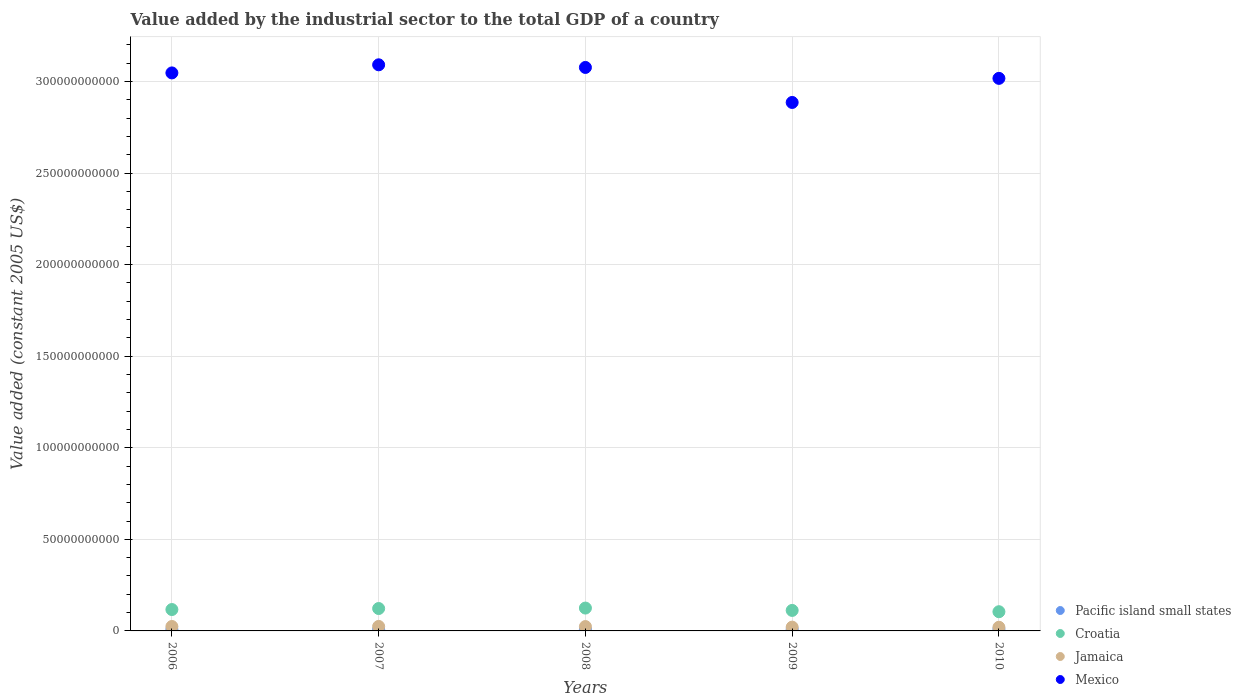Is the number of dotlines equal to the number of legend labels?
Keep it short and to the point. Yes. What is the value added by the industrial sector in Pacific island small states in 2007?
Offer a very short reply. 8.07e+08. Across all years, what is the maximum value added by the industrial sector in Mexico?
Your response must be concise. 3.09e+11. Across all years, what is the minimum value added by the industrial sector in Jamaica?
Provide a short and direct response. 2.00e+09. In which year was the value added by the industrial sector in Jamaica maximum?
Make the answer very short. 2007. What is the total value added by the industrial sector in Pacific island small states in the graph?
Make the answer very short. 4.33e+09. What is the difference between the value added by the industrial sector in Mexico in 2006 and that in 2009?
Make the answer very short. 1.61e+1. What is the difference between the value added by the industrial sector in Croatia in 2006 and the value added by the industrial sector in Pacific island small states in 2008?
Offer a very short reply. 1.08e+1. What is the average value added by the industrial sector in Pacific island small states per year?
Offer a very short reply. 8.65e+08. In the year 2009, what is the difference between the value added by the industrial sector in Jamaica and value added by the industrial sector in Pacific island small states?
Your response must be concise. 1.19e+09. What is the ratio of the value added by the industrial sector in Croatia in 2006 to that in 2008?
Offer a terse response. 0.94. What is the difference between the highest and the second highest value added by the industrial sector in Jamaica?
Your answer should be compact. 3.65e+07. What is the difference between the highest and the lowest value added by the industrial sector in Jamaica?
Provide a succinct answer. 4.54e+08. In how many years, is the value added by the industrial sector in Jamaica greater than the average value added by the industrial sector in Jamaica taken over all years?
Ensure brevity in your answer.  3. Is it the case that in every year, the sum of the value added by the industrial sector in Croatia and value added by the industrial sector in Jamaica  is greater than the sum of value added by the industrial sector in Mexico and value added by the industrial sector in Pacific island small states?
Give a very brief answer. Yes. Does the value added by the industrial sector in Croatia monotonically increase over the years?
Give a very brief answer. No. Is the value added by the industrial sector in Mexico strictly greater than the value added by the industrial sector in Croatia over the years?
Give a very brief answer. Yes. How many dotlines are there?
Offer a terse response. 4. How many years are there in the graph?
Make the answer very short. 5. Are the values on the major ticks of Y-axis written in scientific E-notation?
Provide a short and direct response. No. Where does the legend appear in the graph?
Make the answer very short. Bottom right. How are the legend labels stacked?
Your response must be concise. Vertical. What is the title of the graph?
Offer a very short reply. Value added by the industrial sector to the total GDP of a country. Does "Guam" appear as one of the legend labels in the graph?
Ensure brevity in your answer.  No. What is the label or title of the Y-axis?
Ensure brevity in your answer.  Value added (constant 2005 US$). What is the Value added (constant 2005 US$) of Pacific island small states in 2006?
Offer a very short reply. 8.22e+08. What is the Value added (constant 2005 US$) in Croatia in 2006?
Your answer should be very brief. 1.17e+1. What is the Value added (constant 2005 US$) of Jamaica in 2006?
Provide a short and direct response. 2.42e+09. What is the Value added (constant 2005 US$) in Mexico in 2006?
Your answer should be compact. 3.05e+11. What is the Value added (constant 2005 US$) in Pacific island small states in 2007?
Your answer should be compact. 8.07e+08. What is the Value added (constant 2005 US$) in Croatia in 2007?
Your answer should be compact. 1.22e+1. What is the Value added (constant 2005 US$) of Jamaica in 2007?
Give a very brief answer. 2.46e+09. What is the Value added (constant 2005 US$) of Mexico in 2007?
Make the answer very short. 3.09e+11. What is the Value added (constant 2005 US$) of Pacific island small states in 2008?
Provide a short and direct response. 8.82e+08. What is the Value added (constant 2005 US$) of Croatia in 2008?
Your answer should be very brief. 1.25e+1. What is the Value added (constant 2005 US$) in Jamaica in 2008?
Your answer should be very brief. 2.38e+09. What is the Value added (constant 2005 US$) of Mexico in 2008?
Your response must be concise. 3.08e+11. What is the Value added (constant 2005 US$) of Pacific island small states in 2009?
Give a very brief answer. 8.78e+08. What is the Value added (constant 2005 US$) of Croatia in 2009?
Provide a succinct answer. 1.12e+1. What is the Value added (constant 2005 US$) of Jamaica in 2009?
Your answer should be very brief. 2.07e+09. What is the Value added (constant 2005 US$) of Mexico in 2009?
Make the answer very short. 2.89e+11. What is the Value added (constant 2005 US$) in Pacific island small states in 2010?
Your answer should be compact. 9.36e+08. What is the Value added (constant 2005 US$) of Croatia in 2010?
Ensure brevity in your answer.  1.05e+1. What is the Value added (constant 2005 US$) of Jamaica in 2010?
Make the answer very short. 2.00e+09. What is the Value added (constant 2005 US$) in Mexico in 2010?
Ensure brevity in your answer.  3.02e+11. Across all years, what is the maximum Value added (constant 2005 US$) of Pacific island small states?
Provide a succinct answer. 9.36e+08. Across all years, what is the maximum Value added (constant 2005 US$) in Croatia?
Your answer should be compact. 1.25e+1. Across all years, what is the maximum Value added (constant 2005 US$) in Jamaica?
Keep it short and to the point. 2.46e+09. Across all years, what is the maximum Value added (constant 2005 US$) of Mexico?
Make the answer very short. 3.09e+11. Across all years, what is the minimum Value added (constant 2005 US$) of Pacific island small states?
Ensure brevity in your answer.  8.07e+08. Across all years, what is the minimum Value added (constant 2005 US$) of Croatia?
Your answer should be compact. 1.05e+1. Across all years, what is the minimum Value added (constant 2005 US$) in Jamaica?
Ensure brevity in your answer.  2.00e+09. Across all years, what is the minimum Value added (constant 2005 US$) of Mexico?
Offer a very short reply. 2.89e+11. What is the total Value added (constant 2005 US$) of Pacific island small states in the graph?
Offer a terse response. 4.33e+09. What is the total Value added (constant 2005 US$) in Croatia in the graph?
Offer a very short reply. 5.81e+1. What is the total Value added (constant 2005 US$) in Jamaica in the graph?
Make the answer very short. 1.13e+1. What is the total Value added (constant 2005 US$) in Mexico in the graph?
Your answer should be very brief. 1.51e+12. What is the difference between the Value added (constant 2005 US$) of Pacific island small states in 2006 and that in 2007?
Your response must be concise. 1.49e+07. What is the difference between the Value added (constant 2005 US$) in Croatia in 2006 and that in 2007?
Provide a succinct answer. -5.57e+08. What is the difference between the Value added (constant 2005 US$) of Jamaica in 2006 and that in 2007?
Your answer should be very brief. -3.65e+07. What is the difference between the Value added (constant 2005 US$) of Mexico in 2006 and that in 2007?
Your answer should be compact. -4.43e+09. What is the difference between the Value added (constant 2005 US$) in Pacific island small states in 2006 and that in 2008?
Provide a succinct answer. -6.06e+07. What is the difference between the Value added (constant 2005 US$) of Croatia in 2006 and that in 2008?
Your answer should be very brief. -8.07e+08. What is the difference between the Value added (constant 2005 US$) of Jamaica in 2006 and that in 2008?
Provide a succinct answer. 4.12e+07. What is the difference between the Value added (constant 2005 US$) in Mexico in 2006 and that in 2008?
Offer a terse response. -2.99e+09. What is the difference between the Value added (constant 2005 US$) of Pacific island small states in 2006 and that in 2009?
Give a very brief answer. -5.68e+07. What is the difference between the Value added (constant 2005 US$) of Croatia in 2006 and that in 2009?
Make the answer very short. 4.80e+08. What is the difference between the Value added (constant 2005 US$) in Jamaica in 2006 and that in 2009?
Offer a terse response. 3.49e+08. What is the difference between the Value added (constant 2005 US$) in Mexico in 2006 and that in 2009?
Your answer should be compact. 1.61e+1. What is the difference between the Value added (constant 2005 US$) in Pacific island small states in 2006 and that in 2010?
Keep it short and to the point. -1.15e+08. What is the difference between the Value added (constant 2005 US$) in Croatia in 2006 and that in 2010?
Your response must be concise. 1.19e+09. What is the difference between the Value added (constant 2005 US$) in Jamaica in 2006 and that in 2010?
Offer a terse response. 4.17e+08. What is the difference between the Value added (constant 2005 US$) in Mexico in 2006 and that in 2010?
Offer a very short reply. 2.98e+09. What is the difference between the Value added (constant 2005 US$) in Pacific island small states in 2007 and that in 2008?
Make the answer very short. -7.55e+07. What is the difference between the Value added (constant 2005 US$) in Croatia in 2007 and that in 2008?
Provide a succinct answer. -2.50e+08. What is the difference between the Value added (constant 2005 US$) in Jamaica in 2007 and that in 2008?
Give a very brief answer. 7.76e+07. What is the difference between the Value added (constant 2005 US$) of Mexico in 2007 and that in 2008?
Make the answer very short. 1.44e+09. What is the difference between the Value added (constant 2005 US$) of Pacific island small states in 2007 and that in 2009?
Your answer should be very brief. -7.17e+07. What is the difference between the Value added (constant 2005 US$) of Croatia in 2007 and that in 2009?
Offer a terse response. 1.04e+09. What is the difference between the Value added (constant 2005 US$) in Jamaica in 2007 and that in 2009?
Your answer should be compact. 3.86e+08. What is the difference between the Value added (constant 2005 US$) in Mexico in 2007 and that in 2009?
Keep it short and to the point. 2.06e+1. What is the difference between the Value added (constant 2005 US$) of Pacific island small states in 2007 and that in 2010?
Make the answer very short. -1.30e+08. What is the difference between the Value added (constant 2005 US$) in Croatia in 2007 and that in 2010?
Keep it short and to the point. 1.74e+09. What is the difference between the Value added (constant 2005 US$) of Jamaica in 2007 and that in 2010?
Your response must be concise. 4.54e+08. What is the difference between the Value added (constant 2005 US$) of Mexico in 2007 and that in 2010?
Offer a very short reply. 7.41e+09. What is the difference between the Value added (constant 2005 US$) of Pacific island small states in 2008 and that in 2009?
Offer a terse response. 3.81e+06. What is the difference between the Value added (constant 2005 US$) in Croatia in 2008 and that in 2009?
Offer a very short reply. 1.29e+09. What is the difference between the Value added (constant 2005 US$) of Jamaica in 2008 and that in 2009?
Give a very brief answer. 3.08e+08. What is the difference between the Value added (constant 2005 US$) of Mexico in 2008 and that in 2009?
Your answer should be very brief. 1.91e+1. What is the difference between the Value added (constant 2005 US$) of Pacific island small states in 2008 and that in 2010?
Provide a succinct answer. -5.43e+07. What is the difference between the Value added (constant 2005 US$) of Croatia in 2008 and that in 2010?
Your answer should be compact. 1.99e+09. What is the difference between the Value added (constant 2005 US$) of Jamaica in 2008 and that in 2010?
Your answer should be compact. 3.76e+08. What is the difference between the Value added (constant 2005 US$) of Mexico in 2008 and that in 2010?
Keep it short and to the point. 5.96e+09. What is the difference between the Value added (constant 2005 US$) of Pacific island small states in 2009 and that in 2010?
Ensure brevity in your answer.  -5.81e+07. What is the difference between the Value added (constant 2005 US$) of Croatia in 2009 and that in 2010?
Keep it short and to the point. 7.07e+08. What is the difference between the Value added (constant 2005 US$) in Jamaica in 2009 and that in 2010?
Offer a terse response. 6.83e+07. What is the difference between the Value added (constant 2005 US$) in Mexico in 2009 and that in 2010?
Give a very brief answer. -1.32e+1. What is the difference between the Value added (constant 2005 US$) of Pacific island small states in 2006 and the Value added (constant 2005 US$) of Croatia in 2007?
Ensure brevity in your answer.  -1.14e+1. What is the difference between the Value added (constant 2005 US$) of Pacific island small states in 2006 and the Value added (constant 2005 US$) of Jamaica in 2007?
Your answer should be compact. -1.64e+09. What is the difference between the Value added (constant 2005 US$) in Pacific island small states in 2006 and the Value added (constant 2005 US$) in Mexico in 2007?
Ensure brevity in your answer.  -3.08e+11. What is the difference between the Value added (constant 2005 US$) of Croatia in 2006 and the Value added (constant 2005 US$) of Jamaica in 2007?
Your answer should be very brief. 9.22e+09. What is the difference between the Value added (constant 2005 US$) of Croatia in 2006 and the Value added (constant 2005 US$) of Mexico in 2007?
Provide a succinct answer. -2.97e+11. What is the difference between the Value added (constant 2005 US$) in Jamaica in 2006 and the Value added (constant 2005 US$) in Mexico in 2007?
Your answer should be compact. -3.07e+11. What is the difference between the Value added (constant 2005 US$) in Pacific island small states in 2006 and the Value added (constant 2005 US$) in Croatia in 2008?
Give a very brief answer. -1.17e+1. What is the difference between the Value added (constant 2005 US$) in Pacific island small states in 2006 and the Value added (constant 2005 US$) in Jamaica in 2008?
Make the answer very short. -1.56e+09. What is the difference between the Value added (constant 2005 US$) of Pacific island small states in 2006 and the Value added (constant 2005 US$) of Mexico in 2008?
Your answer should be compact. -3.07e+11. What is the difference between the Value added (constant 2005 US$) of Croatia in 2006 and the Value added (constant 2005 US$) of Jamaica in 2008?
Your answer should be very brief. 9.29e+09. What is the difference between the Value added (constant 2005 US$) in Croatia in 2006 and the Value added (constant 2005 US$) in Mexico in 2008?
Provide a succinct answer. -2.96e+11. What is the difference between the Value added (constant 2005 US$) of Jamaica in 2006 and the Value added (constant 2005 US$) of Mexico in 2008?
Give a very brief answer. -3.05e+11. What is the difference between the Value added (constant 2005 US$) of Pacific island small states in 2006 and the Value added (constant 2005 US$) of Croatia in 2009?
Your answer should be very brief. -1.04e+1. What is the difference between the Value added (constant 2005 US$) of Pacific island small states in 2006 and the Value added (constant 2005 US$) of Jamaica in 2009?
Provide a short and direct response. -1.25e+09. What is the difference between the Value added (constant 2005 US$) in Pacific island small states in 2006 and the Value added (constant 2005 US$) in Mexico in 2009?
Give a very brief answer. -2.88e+11. What is the difference between the Value added (constant 2005 US$) in Croatia in 2006 and the Value added (constant 2005 US$) in Jamaica in 2009?
Ensure brevity in your answer.  9.60e+09. What is the difference between the Value added (constant 2005 US$) in Croatia in 2006 and the Value added (constant 2005 US$) in Mexico in 2009?
Provide a succinct answer. -2.77e+11. What is the difference between the Value added (constant 2005 US$) in Jamaica in 2006 and the Value added (constant 2005 US$) in Mexico in 2009?
Your answer should be very brief. -2.86e+11. What is the difference between the Value added (constant 2005 US$) in Pacific island small states in 2006 and the Value added (constant 2005 US$) in Croatia in 2010?
Your answer should be compact. -9.67e+09. What is the difference between the Value added (constant 2005 US$) of Pacific island small states in 2006 and the Value added (constant 2005 US$) of Jamaica in 2010?
Offer a terse response. -1.18e+09. What is the difference between the Value added (constant 2005 US$) of Pacific island small states in 2006 and the Value added (constant 2005 US$) of Mexico in 2010?
Provide a succinct answer. -3.01e+11. What is the difference between the Value added (constant 2005 US$) in Croatia in 2006 and the Value added (constant 2005 US$) in Jamaica in 2010?
Ensure brevity in your answer.  9.67e+09. What is the difference between the Value added (constant 2005 US$) in Croatia in 2006 and the Value added (constant 2005 US$) in Mexico in 2010?
Provide a succinct answer. -2.90e+11. What is the difference between the Value added (constant 2005 US$) in Jamaica in 2006 and the Value added (constant 2005 US$) in Mexico in 2010?
Your response must be concise. -2.99e+11. What is the difference between the Value added (constant 2005 US$) in Pacific island small states in 2007 and the Value added (constant 2005 US$) in Croatia in 2008?
Ensure brevity in your answer.  -1.17e+1. What is the difference between the Value added (constant 2005 US$) in Pacific island small states in 2007 and the Value added (constant 2005 US$) in Jamaica in 2008?
Your response must be concise. -1.57e+09. What is the difference between the Value added (constant 2005 US$) in Pacific island small states in 2007 and the Value added (constant 2005 US$) in Mexico in 2008?
Provide a short and direct response. -3.07e+11. What is the difference between the Value added (constant 2005 US$) in Croatia in 2007 and the Value added (constant 2005 US$) in Jamaica in 2008?
Provide a short and direct response. 9.85e+09. What is the difference between the Value added (constant 2005 US$) in Croatia in 2007 and the Value added (constant 2005 US$) in Mexico in 2008?
Ensure brevity in your answer.  -2.95e+11. What is the difference between the Value added (constant 2005 US$) in Jamaica in 2007 and the Value added (constant 2005 US$) in Mexico in 2008?
Your answer should be compact. -3.05e+11. What is the difference between the Value added (constant 2005 US$) of Pacific island small states in 2007 and the Value added (constant 2005 US$) of Croatia in 2009?
Your answer should be compact. -1.04e+1. What is the difference between the Value added (constant 2005 US$) in Pacific island small states in 2007 and the Value added (constant 2005 US$) in Jamaica in 2009?
Provide a succinct answer. -1.27e+09. What is the difference between the Value added (constant 2005 US$) of Pacific island small states in 2007 and the Value added (constant 2005 US$) of Mexico in 2009?
Offer a very short reply. -2.88e+11. What is the difference between the Value added (constant 2005 US$) of Croatia in 2007 and the Value added (constant 2005 US$) of Jamaica in 2009?
Your response must be concise. 1.02e+1. What is the difference between the Value added (constant 2005 US$) in Croatia in 2007 and the Value added (constant 2005 US$) in Mexico in 2009?
Provide a short and direct response. -2.76e+11. What is the difference between the Value added (constant 2005 US$) of Jamaica in 2007 and the Value added (constant 2005 US$) of Mexico in 2009?
Ensure brevity in your answer.  -2.86e+11. What is the difference between the Value added (constant 2005 US$) in Pacific island small states in 2007 and the Value added (constant 2005 US$) in Croatia in 2010?
Offer a very short reply. -9.68e+09. What is the difference between the Value added (constant 2005 US$) of Pacific island small states in 2007 and the Value added (constant 2005 US$) of Jamaica in 2010?
Offer a very short reply. -1.20e+09. What is the difference between the Value added (constant 2005 US$) in Pacific island small states in 2007 and the Value added (constant 2005 US$) in Mexico in 2010?
Your answer should be very brief. -3.01e+11. What is the difference between the Value added (constant 2005 US$) of Croatia in 2007 and the Value added (constant 2005 US$) of Jamaica in 2010?
Ensure brevity in your answer.  1.02e+1. What is the difference between the Value added (constant 2005 US$) of Croatia in 2007 and the Value added (constant 2005 US$) of Mexico in 2010?
Make the answer very short. -2.89e+11. What is the difference between the Value added (constant 2005 US$) of Jamaica in 2007 and the Value added (constant 2005 US$) of Mexico in 2010?
Provide a succinct answer. -2.99e+11. What is the difference between the Value added (constant 2005 US$) of Pacific island small states in 2008 and the Value added (constant 2005 US$) of Croatia in 2009?
Give a very brief answer. -1.03e+1. What is the difference between the Value added (constant 2005 US$) of Pacific island small states in 2008 and the Value added (constant 2005 US$) of Jamaica in 2009?
Offer a very short reply. -1.19e+09. What is the difference between the Value added (constant 2005 US$) of Pacific island small states in 2008 and the Value added (constant 2005 US$) of Mexico in 2009?
Ensure brevity in your answer.  -2.88e+11. What is the difference between the Value added (constant 2005 US$) of Croatia in 2008 and the Value added (constant 2005 US$) of Jamaica in 2009?
Ensure brevity in your answer.  1.04e+1. What is the difference between the Value added (constant 2005 US$) of Croatia in 2008 and the Value added (constant 2005 US$) of Mexico in 2009?
Your answer should be very brief. -2.76e+11. What is the difference between the Value added (constant 2005 US$) of Jamaica in 2008 and the Value added (constant 2005 US$) of Mexico in 2009?
Your answer should be very brief. -2.86e+11. What is the difference between the Value added (constant 2005 US$) of Pacific island small states in 2008 and the Value added (constant 2005 US$) of Croatia in 2010?
Offer a very short reply. -9.60e+09. What is the difference between the Value added (constant 2005 US$) in Pacific island small states in 2008 and the Value added (constant 2005 US$) in Jamaica in 2010?
Give a very brief answer. -1.12e+09. What is the difference between the Value added (constant 2005 US$) of Pacific island small states in 2008 and the Value added (constant 2005 US$) of Mexico in 2010?
Ensure brevity in your answer.  -3.01e+11. What is the difference between the Value added (constant 2005 US$) of Croatia in 2008 and the Value added (constant 2005 US$) of Jamaica in 2010?
Your answer should be compact. 1.05e+1. What is the difference between the Value added (constant 2005 US$) in Croatia in 2008 and the Value added (constant 2005 US$) in Mexico in 2010?
Keep it short and to the point. -2.89e+11. What is the difference between the Value added (constant 2005 US$) of Jamaica in 2008 and the Value added (constant 2005 US$) of Mexico in 2010?
Ensure brevity in your answer.  -2.99e+11. What is the difference between the Value added (constant 2005 US$) in Pacific island small states in 2009 and the Value added (constant 2005 US$) in Croatia in 2010?
Provide a succinct answer. -9.61e+09. What is the difference between the Value added (constant 2005 US$) of Pacific island small states in 2009 and the Value added (constant 2005 US$) of Jamaica in 2010?
Offer a very short reply. -1.13e+09. What is the difference between the Value added (constant 2005 US$) in Pacific island small states in 2009 and the Value added (constant 2005 US$) in Mexico in 2010?
Keep it short and to the point. -3.01e+11. What is the difference between the Value added (constant 2005 US$) in Croatia in 2009 and the Value added (constant 2005 US$) in Jamaica in 2010?
Your answer should be very brief. 9.19e+09. What is the difference between the Value added (constant 2005 US$) in Croatia in 2009 and the Value added (constant 2005 US$) in Mexico in 2010?
Provide a short and direct response. -2.90e+11. What is the difference between the Value added (constant 2005 US$) of Jamaica in 2009 and the Value added (constant 2005 US$) of Mexico in 2010?
Your answer should be very brief. -3.00e+11. What is the average Value added (constant 2005 US$) of Pacific island small states per year?
Your response must be concise. 8.65e+08. What is the average Value added (constant 2005 US$) of Croatia per year?
Your response must be concise. 1.16e+1. What is the average Value added (constant 2005 US$) of Jamaica per year?
Make the answer very short. 2.27e+09. What is the average Value added (constant 2005 US$) in Mexico per year?
Offer a very short reply. 3.02e+11. In the year 2006, what is the difference between the Value added (constant 2005 US$) of Pacific island small states and Value added (constant 2005 US$) of Croatia?
Make the answer very short. -1.09e+1. In the year 2006, what is the difference between the Value added (constant 2005 US$) of Pacific island small states and Value added (constant 2005 US$) of Jamaica?
Your answer should be very brief. -1.60e+09. In the year 2006, what is the difference between the Value added (constant 2005 US$) of Pacific island small states and Value added (constant 2005 US$) of Mexico?
Provide a succinct answer. -3.04e+11. In the year 2006, what is the difference between the Value added (constant 2005 US$) of Croatia and Value added (constant 2005 US$) of Jamaica?
Provide a succinct answer. 9.25e+09. In the year 2006, what is the difference between the Value added (constant 2005 US$) in Croatia and Value added (constant 2005 US$) in Mexico?
Your answer should be very brief. -2.93e+11. In the year 2006, what is the difference between the Value added (constant 2005 US$) of Jamaica and Value added (constant 2005 US$) of Mexico?
Offer a terse response. -3.02e+11. In the year 2007, what is the difference between the Value added (constant 2005 US$) of Pacific island small states and Value added (constant 2005 US$) of Croatia?
Your response must be concise. -1.14e+1. In the year 2007, what is the difference between the Value added (constant 2005 US$) of Pacific island small states and Value added (constant 2005 US$) of Jamaica?
Give a very brief answer. -1.65e+09. In the year 2007, what is the difference between the Value added (constant 2005 US$) of Pacific island small states and Value added (constant 2005 US$) of Mexico?
Provide a succinct answer. -3.08e+11. In the year 2007, what is the difference between the Value added (constant 2005 US$) in Croatia and Value added (constant 2005 US$) in Jamaica?
Give a very brief answer. 9.77e+09. In the year 2007, what is the difference between the Value added (constant 2005 US$) of Croatia and Value added (constant 2005 US$) of Mexico?
Your answer should be compact. -2.97e+11. In the year 2007, what is the difference between the Value added (constant 2005 US$) of Jamaica and Value added (constant 2005 US$) of Mexico?
Make the answer very short. -3.07e+11. In the year 2008, what is the difference between the Value added (constant 2005 US$) in Pacific island small states and Value added (constant 2005 US$) in Croatia?
Offer a terse response. -1.16e+1. In the year 2008, what is the difference between the Value added (constant 2005 US$) of Pacific island small states and Value added (constant 2005 US$) of Jamaica?
Provide a succinct answer. -1.50e+09. In the year 2008, what is the difference between the Value added (constant 2005 US$) of Pacific island small states and Value added (constant 2005 US$) of Mexico?
Offer a terse response. -3.07e+11. In the year 2008, what is the difference between the Value added (constant 2005 US$) of Croatia and Value added (constant 2005 US$) of Jamaica?
Offer a very short reply. 1.01e+1. In the year 2008, what is the difference between the Value added (constant 2005 US$) of Croatia and Value added (constant 2005 US$) of Mexico?
Give a very brief answer. -2.95e+11. In the year 2008, what is the difference between the Value added (constant 2005 US$) of Jamaica and Value added (constant 2005 US$) of Mexico?
Offer a terse response. -3.05e+11. In the year 2009, what is the difference between the Value added (constant 2005 US$) in Pacific island small states and Value added (constant 2005 US$) in Croatia?
Keep it short and to the point. -1.03e+1. In the year 2009, what is the difference between the Value added (constant 2005 US$) in Pacific island small states and Value added (constant 2005 US$) in Jamaica?
Your answer should be compact. -1.19e+09. In the year 2009, what is the difference between the Value added (constant 2005 US$) of Pacific island small states and Value added (constant 2005 US$) of Mexico?
Offer a terse response. -2.88e+11. In the year 2009, what is the difference between the Value added (constant 2005 US$) in Croatia and Value added (constant 2005 US$) in Jamaica?
Offer a very short reply. 9.12e+09. In the year 2009, what is the difference between the Value added (constant 2005 US$) of Croatia and Value added (constant 2005 US$) of Mexico?
Your answer should be very brief. -2.77e+11. In the year 2009, what is the difference between the Value added (constant 2005 US$) in Jamaica and Value added (constant 2005 US$) in Mexico?
Give a very brief answer. -2.86e+11. In the year 2010, what is the difference between the Value added (constant 2005 US$) in Pacific island small states and Value added (constant 2005 US$) in Croatia?
Offer a terse response. -9.55e+09. In the year 2010, what is the difference between the Value added (constant 2005 US$) of Pacific island small states and Value added (constant 2005 US$) of Jamaica?
Ensure brevity in your answer.  -1.07e+09. In the year 2010, what is the difference between the Value added (constant 2005 US$) in Pacific island small states and Value added (constant 2005 US$) in Mexico?
Ensure brevity in your answer.  -3.01e+11. In the year 2010, what is the difference between the Value added (constant 2005 US$) in Croatia and Value added (constant 2005 US$) in Jamaica?
Offer a very short reply. 8.48e+09. In the year 2010, what is the difference between the Value added (constant 2005 US$) in Croatia and Value added (constant 2005 US$) in Mexico?
Ensure brevity in your answer.  -2.91e+11. In the year 2010, what is the difference between the Value added (constant 2005 US$) in Jamaica and Value added (constant 2005 US$) in Mexico?
Provide a short and direct response. -3.00e+11. What is the ratio of the Value added (constant 2005 US$) of Pacific island small states in 2006 to that in 2007?
Offer a very short reply. 1.02. What is the ratio of the Value added (constant 2005 US$) of Croatia in 2006 to that in 2007?
Your response must be concise. 0.95. What is the ratio of the Value added (constant 2005 US$) of Jamaica in 2006 to that in 2007?
Provide a short and direct response. 0.99. What is the ratio of the Value added (constant 2005 US$) in Mexico in 2006 to that in 2007?
Your answer should be very brief. 0.99. What is the ratio of the Value added (constant 2005 US$) in Pacific island small states in 2006 to that in 2008?
Your answer should be compact. 0.93. What is the ratio of the Value added (constant 2005 US$) in Croatia in 2006 to that in 2008?
Make the answer very short. 0.94. What is the ratio of the Value added (constant 2005 US$) of Jamaica in 2006 to that in 2008?
Your answer should be very brief. 1.02. What is the ratio of the Value added (constant 2005 US$) of Mexico in 2006 to that in 2008?
Your answer should be compact. 0.99. What is the ratio of the Value added (constant 2005 US$) of Pacific island small states in 2006 to that in 2009?
Offer a terse response. 0.94. What is the ratio of the Value added (constant 2005 US$) in Croatia in 2006 to that in 2009?
Your answer should be compact. 1.04. What is the ratio of the Value added (constant 2005 US$) of Jamaica in 2006 to that in 2009?
Ensure brevity in your answer.  1.17. What is the ratio of the Value added (constant 2005 US$) in Mexico in 2006 to that in 2009?
Provide a succinct answer. 1.06. What is the ratio of the Value added (constant 2005 US$) of Pacific island small states in 2006 to that in 2010?
Provide a succinct answer. 0.88. What is the ratio of the Value added (constant 2005 US$) of Croatia in 2006 to that in 2010?
Your response must be concise. 1.11. What is the ratio of the Value added (constant 2005 US$) of Jamaica in 2006 to that in 2010?
Give a very brief answer. 1.21. What is the ratio of the Value added (constant 2005 US$) of Mexico in 2006 to that in 2010?
Provide a short and direct response. 1.01. What is the ratio of the Value added (constant 2005 US$) of Pacific island small states in 2007 to that in 2008?
Keep it short and to the point. 0.91. What is the ratio of the Value added (constant 2005 US$) of Croatia in 2007 to that in 2008?
Keep it short and to the point. 0.98. What is the ratio of the Value added (constant 2005 US$) of Jamaica in 2007 to that in 2008?
Keep it short and to the point. 1.03. What is the ratio of the Value added (constant 2005 US$) of Mexico in 2007 to that in 2008?
Provide a short and direct response. 1. What is the ratio of the Value added (constant 2005 US$) of Pacific island small states in 2007 to that in 2009?
Provide a succinct answer. 0.92. What is the ratio of the Value added (constant 2005 US$) in Croatia in 2007 to that in 2009?
Provide a succinct answer. 1.09. What is the ratio of the Value added (constant 2005 US$) in Jamaica in 2007 to that in 2009?
Ensure brevity in your answer.  1.19. What is the ratio of the Value added (constant 2005 US$) in Mexico in 2007 to that in 2009?
Offer a very short reply. 1.07. What is the ratio of the Value added (constant 2005 US$) of Pacific island small states in 2007 to that in 2010?
Ensure brevity in your answer.  0.86. What is the ratio of the Value added (constant 2005 US$) in Croatia in 2007 to that in 2010?
Offer a terse response. 1.17. What is the ratio of the Value added (constant 2005 US$) in Jamaica in 2007 to that in 2010?
Offer a terse response. 1.23. What is the ratio of the Value added (constant 2005 US$) of Mexico in 2007 to that in 2010?
Your response must be concise. 1.02. What is the ratio of the Value added (constant 2005 US$) of Croatia in 2008 to that in 2009?
Keep it short and to the point. 1.11. What is the ratio of the Value added (constant 2005 US$) of Jamaica in 2008 to that in 2009?
Offer a terse response. 1.15. What is the ratio of the Value added (constant 2005 US$) in Mexico in 2008 to that in 2009?
Ensure brevity in your answer.  1.07. What is the ratio of the Value added (constant 2005 US$) in Pacific island small states in 2008 to that in 2010?
Offer a terse response. 0.94. What is the ratio of the Value added (constant 2005 US$) in Croatia in 2008 to that in 2010?
Make the answer very short. 1.19. What is the ratio of the Value added (constant 2005 US$) in Jamaica in 2008 to that in 2010?
Your answer should be very brief. 1.19. What is the ratio of the Value added (constant 2005 US$) of Mexico in 2008 to that in 2010?
Ensure brevity in your answer.  1.02. What is the ratio of the Value added (constant 2005 US$) of Pacific island small states in 2009 to that in 2010?
Ensure brevity in your answer.  0.94. What is the ratio of the Value added (constant 2005 US$) of Croatia in 2009 to that in 2010?
Offer a terse response. 1.07. What is the ratio of the Value added (constant 2005 US$) in Jamaica in 2009 to that in 2010?
Your response must be concise. 1.03. What is the ratio of the Value added (constant 2005 US$) of Mexico in 2009 to that in 2010?
Offer a very short reply. 0.96. What is the difference between the highest and the second highest Value added (constant 2005 US$) of Pacific island small states?
Offer a very short reply. 5.43e+07. What is the difference between the highest and the second highest Value added (constant 2005 US$) of Croatia?
Give a very brief answer. 2.50e+08. What is the difference between the highest and the second highest Value added (constant 2005 US$) of Jamaica?
Your answer should be compact. 3.65e+07. What is the difference between the highest and the second highest Value added (constant 2005 US$) in Mexico?
Make the answer very short. 1.44e+09. What is the difference between the highest and the lowest Value added (constant 2005 US$) of Pacific island small states?
Provide a succinct answer. 1.30e+08. What is the difference between the highest and the lowest Value added (constant 2005 US$) of Croatia?
Keep it short and to the point. 1.99e+09. What is the difference between the highest and the lowest Value added (constant 2005 US$) in Jamaica?
Your answer should be very brief. 4.54e+08. What is the difference between the highest and the lowest Value added (constant 2005 US$) in Mexico?
Ensure brevity in your answer.  2.06e+1. 